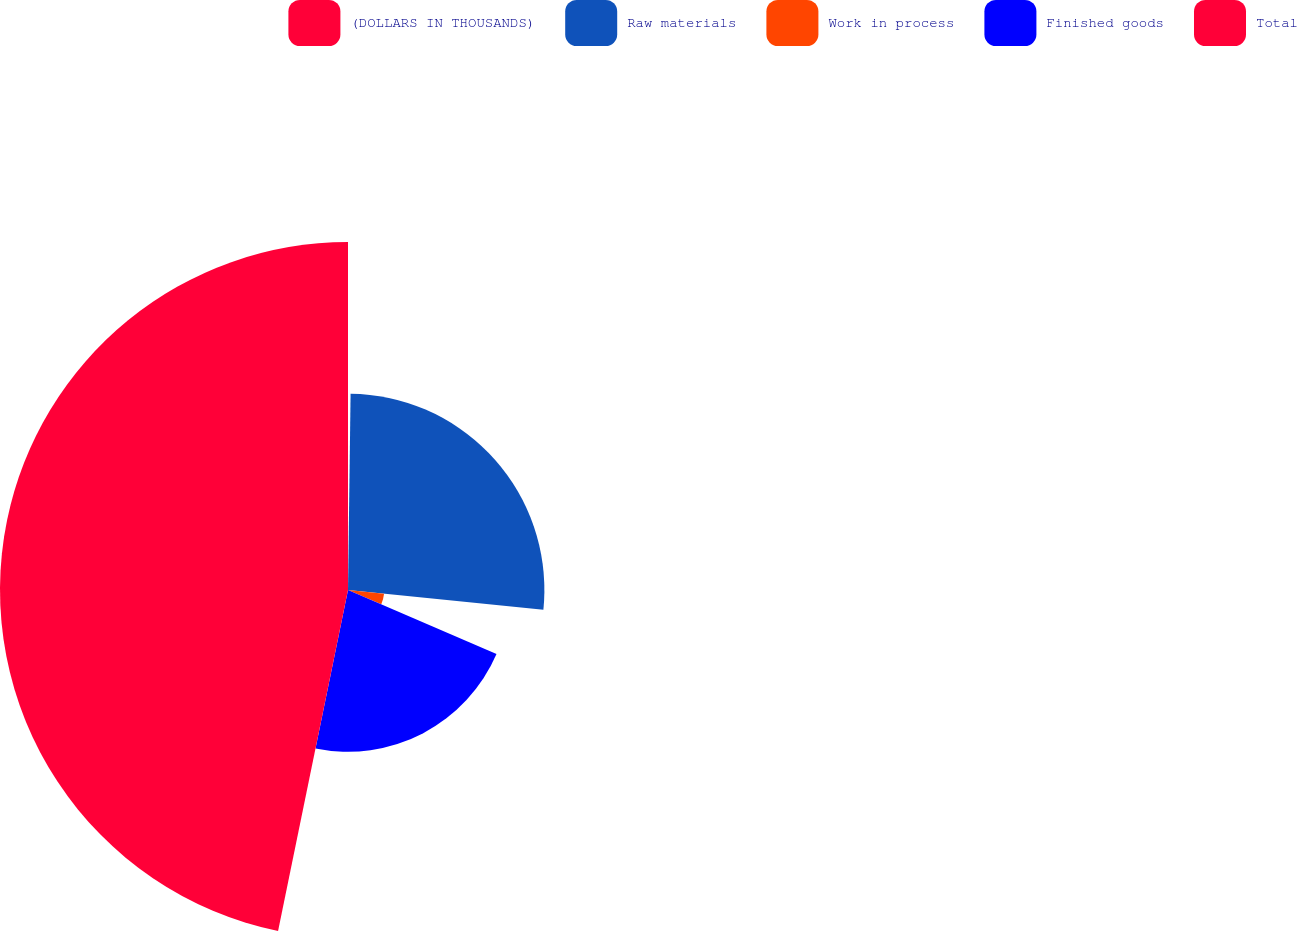<chart> <loc_0><loc_0><loc_500><loc_500><pie_chart><fcel>(DOLLARS IN THOUSANDS)<fcel>Raw materials<fcel>Work in process<fcel>Finished goods<fcel>Total<nl><fcel>0.21%<fcel>26.4%<fcel>4.87%<fcel>21.74%<fcel>46.78%<nl></chart> 